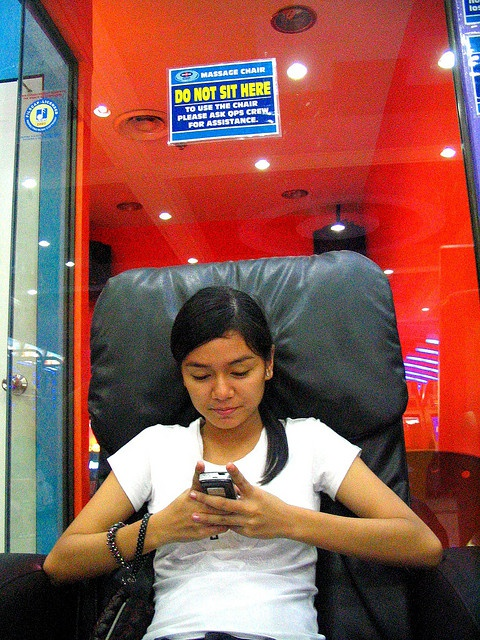Describe the objects in this image and their specific colors. I can see people in lightblue, white, black, brown, and tan tones, chair in lightblue, black, purple, teal, and darkgreen tones, handbag in lightblue, black, gray, maroon, and olive tones, and cell phone in lightblue, black, white, gray, and darkgray tones in this image. 